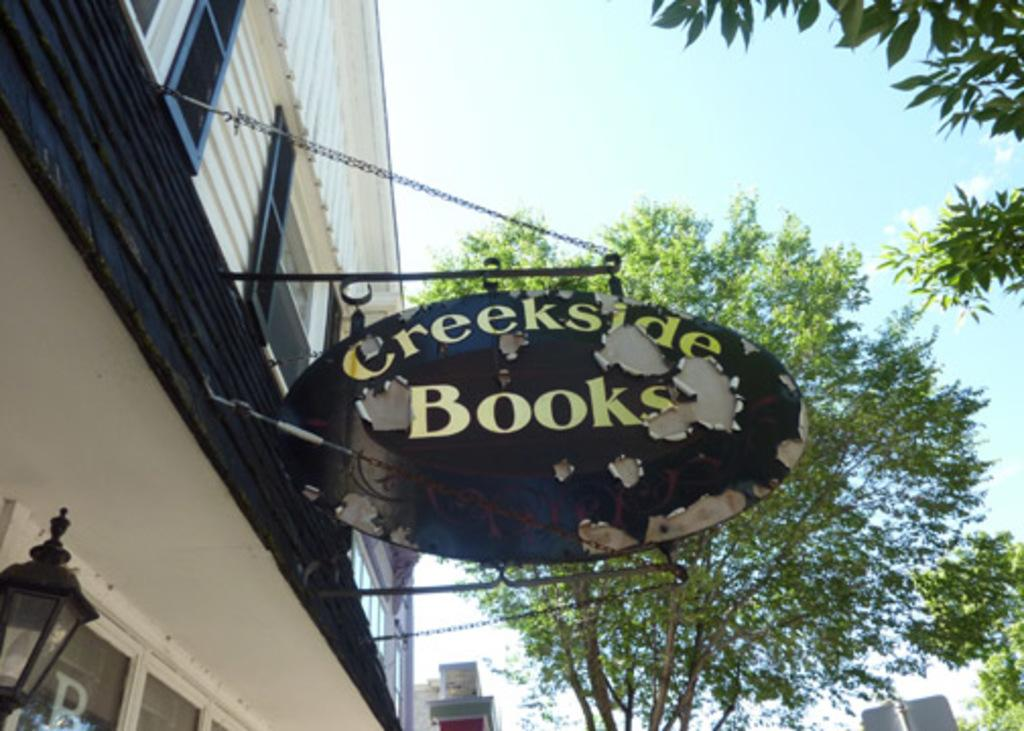What is attached to the wall in the image? There is a name board fixed to a wall in the image. What other objects can be seen in the image? There is a lamp visible in the image. What can be seen in the background of the image? Buildings, trees, and the sky are visible in the background of the image. What reward does the mom give to the passenger in the image? There is no mom or passenger present in the image, so there is no reward being given. 